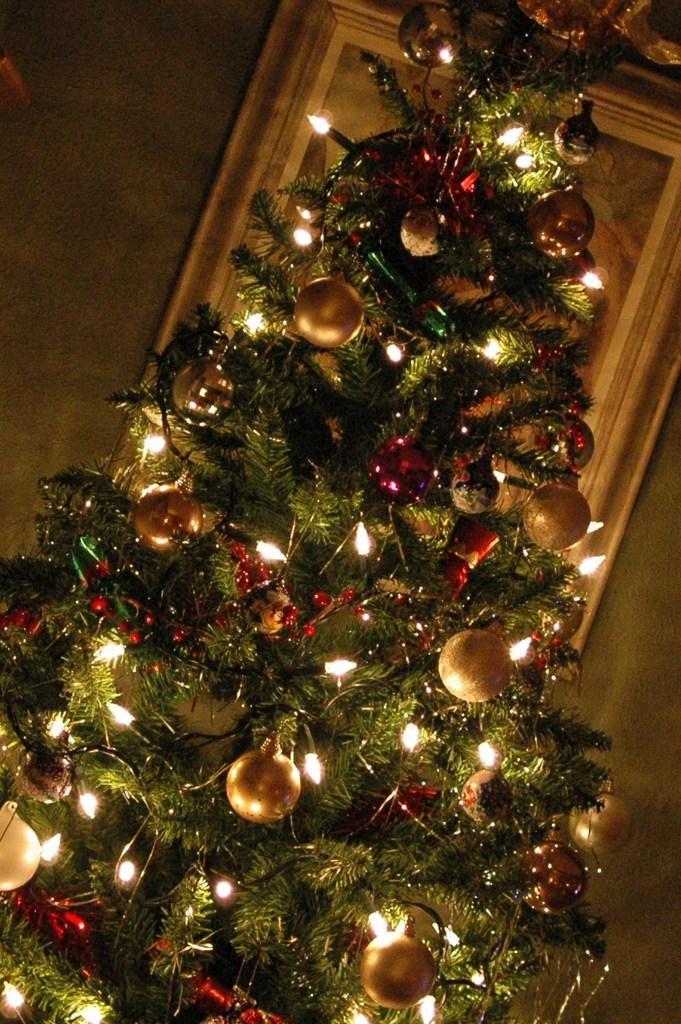Please provide a concise description of this image. In this picture we can see a christmas tree with lights on it. 